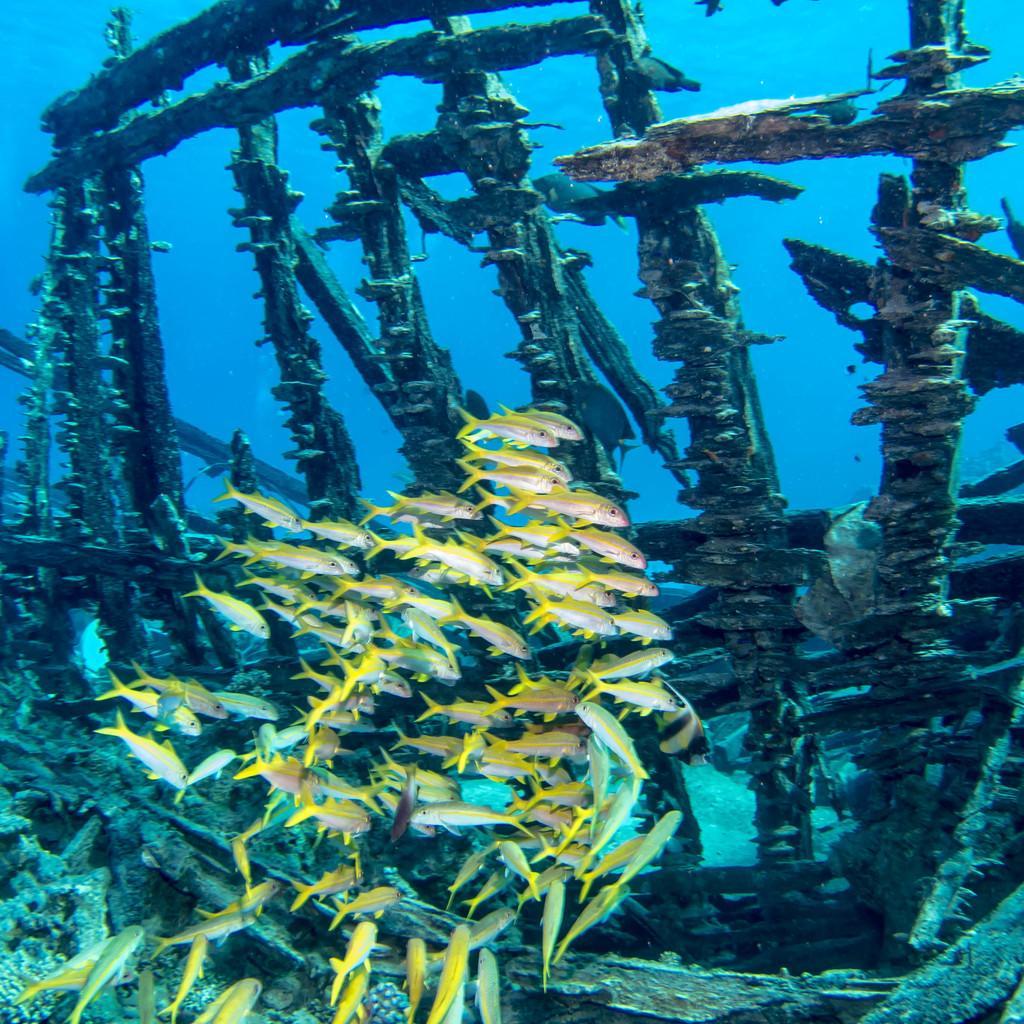Describe this image in one or two sentences. In this picture I can see there are many fishes which have yellow color tails and they are swimming in the sea, there is a wooden frame in the water. 